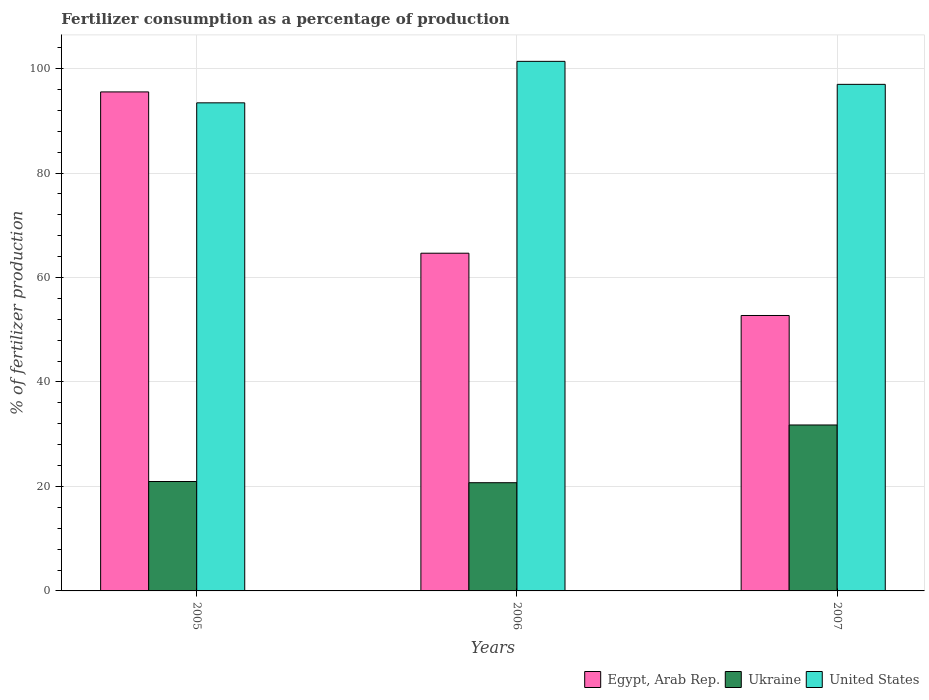How many groups of bars are there?
Your answer should be compact. 3. Are the number of bars per tick equal to the number of legend labels?
Give a very brief answer. Yes. How many bars are there on the 1st tick from the left?
Provide a short and direct response. 3. What is the label of the 2nd group of bars from the left?
Give a very brief answer. 2006. In how many cases, is the number of bars for a given year not equal to the number of legend labels?
Offer a terse response. 0. What is the percentage of fertilizers consumed in Egypt, Arab Rep. in 2007?
Your response must be concise. 52.73. Across all years, what is the maximum percentage of fertilizers consumed in Ukraine?
Give a very brief answer. 31.77. Across all years, what is the minimum percentage of fertilizers consumed in United States?
Provide a short and direct response. 93.44. In which year was the percentage of fertilizers consumed in United States minimum?
Your response must be concise. 2005. What is the total percentage of fertilizers consumed in Egypt, Arab Rep. in the graph?
Keep it short and to the point. 212.92. What is the difference between the percentage of fertilizers consumed in Egypt, Arab Rep. in 2005 and that in 2006?
Offer a terse response. 30.88. What is the difference between the percentage of fertilizers consumed in Egypt, Arab Rep. in 2005 and the percentage of fertilizers consumed in Ukraine in 2006?
Your response must be concise. 74.82. What is the average percentage of fertilizers consumed in Ukraine per year?
Your answer should be compact. 24.48. In the year 2007, what is the difference between the percentage of fertilizers consumed in Egypt, Arab Rep. and percentage of fertilizers consumed in Ukraine?
Keep it short and to the point. 20.96. In how many years, is the percentage of fertilizers consumed in Ukraine greater than 68 %?
Make the answer very short. 0. What is the ratio of the percentage of fertilizers consumed in United States in 2006 to that in 2007?
Your response must be concise. 1.05. What is the difference between the highest and the second highest percentage of fertilizers consumed in United States?
Your answer should be compact. 4.4. What is the difference between the highest and the lowest percentage of fertilizers consumed in Ukraine?
Offer a terse response. 11.05. In how many years, is the percentage of fertilizers consumed in United States greater than the average percentage of fertilizers consumed in United States taken over all years?
Your answer should be very brief. 1. Is the sum of the percentage of fertilizers consumed in Ukraine in 2005 and 2007 greater than the maximum percentage of fertilizers consumed in United States across all years?
Your response must be concise. No. Is it the case that in every year, the sum of the percentage of fertilizers consumed in Egypt, Arab Rep. and percentage of fertilizers consumed in United States is greater than the percentage of fertilizers consumed in Ukraine?
Give a very brief answer. Yes. Are all the bars in the graph horizontal?
Provide a succinct answer. No. How many years are there in the graph?
Provide a short and direct response. 3. What is the difference between two consecutive major ticks on the Y-axis?
Provide a short and direct response. 20. Does the graph contain any zero values?
Your answer should be compact. No. Does the graph contain grids?
Offer a very short reply. Yes. How many legend labels are there?
Provide a short and direct response. 3. What is the title of the graph?
Give a very brief answer. Fertilizer consumption as a percentage of production. Does "El Salvador" appear as one of the legend labels in the graph?
Your answer should be very brief. No. What is the label or title of the Y-axis?
Provide a succinct answer. % of fertilizer production. What is the % of fertilizer production in Egypt, Arab Rep. in 2005?
Offer a very short reply. 95.53. What is the % of fertilizer production in Ukraine in 2005?
Provide a short and direct response. 20.95. What is the % of fertilizer production of United States in 2005?
Give a very brief answer. 93.44. What is the % of fertilizer production of Egypt, Arab Rep. in 2006?
Your response must be concise. 64.65. What is the % of fertilizer production of Ukraine in 2006?
Provide a succinct answer. 20.72. What is the % of fertilizer production of United States in 2006?
Offer a terse response. 101.38. What is the % of fertilizer production in Egypt, Arab Rep. in 2007?
Your response must be concise. 52.73. What is the % of fertilizer production in Ukraine in 2007?
Keep it short and to the point. 31.77. What is the % of fertilizer production of United States in 2007?
Your response must be concise. 96.98. Across all years, what is the maximum % of fertilizer production in Egypt, Arab Rep.?
Ensure brevity in your answer.  95.53. Across all years, what is the maximum % of fertilizer production in Ukraine?
Give a very brief answer. 31.77. Across all years, what is the maximum % of fertilizer production of United States?
Ensure brevity in your answer.  101.38. Across all years, what is the minimum % of fertilizer production in Egypt, Arab Rep.?
Provide a succinct answer. 52.73. Across all years, what is the minimum % of fertilizer production in Ukraine?
Ensure brevity in your answer.  20.72. Across all years, what is the minimum % of fertilizer production in United States?
Provide a succinct answer. 93.44. What is the total % of fertilizer production of Egypt, Arab Rep. in the graph?
Your answer should be compact. 212.92. What is the total % of fertilizer production in Ukraine in the graph?
Ensure brevity in your answer.  73.43. What is the total % of fertilizer production of United States in the graph?
Ensure brevity in your answer.  291.81. What is the difference between the % of fertilizer production in Egypt, Arab Rep. in 2005 and that in 2006?
Give a very brief answer. 30.88. What is the difference between the % of fertilizer production of Ukraine in 2005 and that in 2006?
Keep it short and to the point. 0.23. What is the difference between the % of fertilizer production in United States in 2005 and that in 2006?
Offer a terse response. -7.94. What is the difference between the % of fertilizer production in Egypt, Arab Rep. in 2005 and that in 2007?
Offer a very short reply. 42.8. What is the difference between the % of fertilizer production in Ukraine in 2005 and that in 2007?
Provide a short and direct response. -10.82. What is the difference between the % of fertilizer production of United States in 2005 and that in 2007?
Offer a very short reply. -3.54. What is the difference between the % of fertilizer production of Egypt, Arab Rep. in 2006 and that in 2007?
Provide a succinct answer. 11.92. What is the difference between the % of fertilizer production of Ukraine in 2006 and that in 2007?
Your answer should be very brief. -11.05. What is the difference between the % of fertilizer production of United States in 2006 and that in 2007?
Keep it short and to the point. 4.4. What is the difference between the % of fertilizer production of Egypt, Arab Rep. in 2005 and the % of fertilizer production of Ukraine in 2006?
Provide a succinct answer. 74.82. What is the difference between the % of fertilizer production of Egypt, Arab Rep. in 2005 and the % of fertilizer production of United States in 2006?
Give a very brief answer. -5.85. What is the difference between the % of fertilizer production of Ukraine in 2005 and the % of fertilizer production of United States in 2006?
Offer a terse response. -80.44. What is the difference between the % of fertilizer production in Egypt, Arab Rep. in 2005 and the % of fertilizer production in Ukraine in 2007?
Offer a very short reply. 63.77. What is the difference between the % of fertilizer production of Egypt, Arab Rep. in 2005 and the % of fertilizer production of United States in 2007?
Ensure brevity in your answer.  -1.45. What is the difference between the % of fertilizer production in Ukraine in 2005 and the % of fertilizer production in United States in 2007?
Offer a very short reply. -76.03. What is the difference between the % of fertilizer production of Egypt, Arab Rep. in 2006 and the % of fertilizer production of Ukraine in 2007?
Keep it short and to the point. 32.88. What is the difference between the % of fertilizer production in Egypt, Arab Rep. in 2006 and the % of fertilizer production in United States in 2007?
Give a very brief answer. -32.33. What is the difference between the % of fertilizer production in Ukraine in 2006 and the % of fertilizer production in United States in 2007?
Offer a terse response. -76.26. What is the average % of fertilizer production of Egypt, Arab Rep. per year?
Ensure brevity in your answer.  70.97. What is the average % of fertilizer production in Ukraine per year?
Make the answer very short. 24.48. What is the average % of fertilizer production of United States per year?
Keep it short and to the point. 97.27. In the year 2005, what is the difference between the % of fertilizer production of Egypt, Arab Rep. and % of fertilizer production of Ukraine?
Offer a very short reply. 74.59. In the year 2005, what is the difference between the % of fertilizer production in Egypt, Arab Rep. and % of fertilizer production in United States?
Your response must be concise. 2.09. In the year 2005, what is the difference between the % of fertilizer production of Ukraine and % of fertilizer production of United States?
Keep it short and to the point. -72.5. In the year 2006, what is the difference between the % of fertilizer production of Egypt, Arab Rep. and % of fertilizer production of Ukraine?
Offer a terse response. 43.94. In the year 2006, what is the difference between the % of fertilizer production of Egypt, Arab Rep. and % of fertilizer production of United States?
Offer a very short reply. -36.73. In the year 2006, what is the difference between the % of fertilizer production of Ukraine and % of fertilizer production of United States?
Offer a terse response. -80.67. In the year 2007, what is the difference between the % of fertilizer production in Egypt, Arab Rep. and % of fertilizer production in Ukraine?
Make the answer very short. 20.96. In the year 2007, what is the difference between the % of fertilizer production of Egypt, Arab Rep. and % of fertilizer production of United States?
Offer a very short reply. -44.25. In the year 2007, what is the difference between the % of fertilizer production in Ukraine and % of fertilizer production in United States?
Your answer should be compact. -65.21. What is the ratio of the % of fertilizer production of Egypt, Arab Rep. in 2005 to that in 2006?
Provide a short and direct response. 1.48. What is the ratio of the % of fertilizer production of Ukraine in 2005 to that in 2006?
Provide a short and direct response. 1.01. What is the ratio of the % of fertilizer production in United States in 2005 to that in 2006?
Ensure brevity in your answer.  0.92. What is the ratio of the % of fertilizer production of Egypt, Arab Rep. in 2005 to that in 2007?
Offer a terse response. 1.81. What is the ratio of the % of fertilizer production in Ukraine in 2005 to that in 2007?
Your answer should be compact. 0.66. What is the ratio of the % of fertilizer production of United States in 2005 to that in 2007?
Give a very brief answer. 0.96. What is the ratio of the % of fertilizer production of Egypt, Arab Rep. in 2006 to that in 2007?
Give a very brief answer. 1.23. What is the ratio of the % of fertilizer production in Ukraine in 2006 to that in 2007?
Your answer should be very brief. 0.65. What is the ratio of the % of fertilizer production in United States in 2006 to that in 2007?
Offer a terse response. 1.05. What is the difference between the highest and the second highest % of fertilizer production of Egypt, Arab Rep.?
Your answer should be compact. 30.88. What is the difference between the highest and the second highest % of fertilizer production of Ukraine?
Provide a succinct answer. 10.82. What is the difference between the highest and the second highest % of fertilizer production of United States?
Ensure brevity in your answer.  4.4. What is the difference between the highest and the lowest % of fertilizer production in Egypt, Arab Rep.?
Your response must be concise. 42.8. What is the difference between the highest and the lowest % of fertilizer production in Ukraine?
Offer a very short reply. 11.05. What is the difference between the highest and the lowest % of fertilizer production of United States?
Offer a terse response. 7.94. 